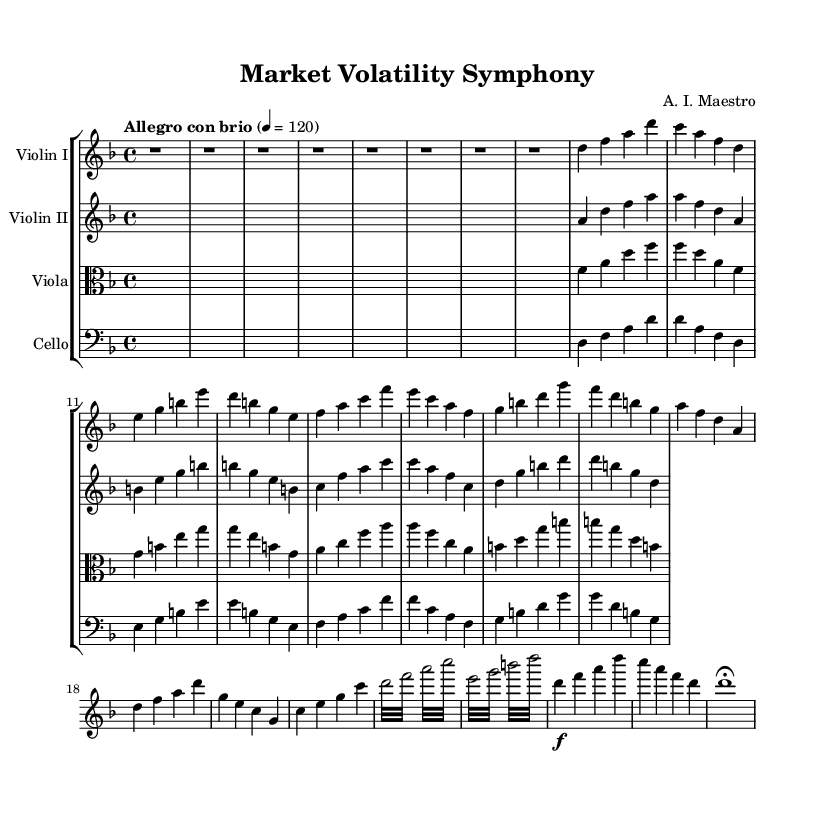What is the key signature of this music? The key signature is indicated at the start of the score. In this case, it is D minor, which has one flat (B flat).
Answer: D minor What is the time signature of this piece? The time signature is found at the beginning of the score, which indicates how many beats are in each measure. Here, it shows 4/4, meaning there are 4 beats in a measure.
Answer: 4/4 What is the tempo marking for this symphony? The tempo marking is located near the beginning of the score, specifically stating the speed of the piece. The marking “Allegro con brio” with a metronome marking of 120 indicates a lively and brisk tempo.
Answer: Allegro con brio How many parts are written for the strings in this piece? The score displays four distinct parts: Violin I, Violin II, Viola, and Cello. Each part is written on its own staff, indicating a total of four parts.
Answer: Four Which theme represents the Bull Market? The "Theme A - Bull Market" section is indicated explicitly at the score, characterized by an uplifting and harmonious melody. In this case, it starts with the notes d, f, a, and continues with a progression typical for a bullish sentiment.
Answer: Theme A Which theme is simplified as the Bear Market? “Theme B - Bear Market (simplified)” is clearly labeled in the score, presenting a simpler melodic pattern that denotes a downward market sentiment. It begins with the notes a, f, d, a.
Answer: Theme B 